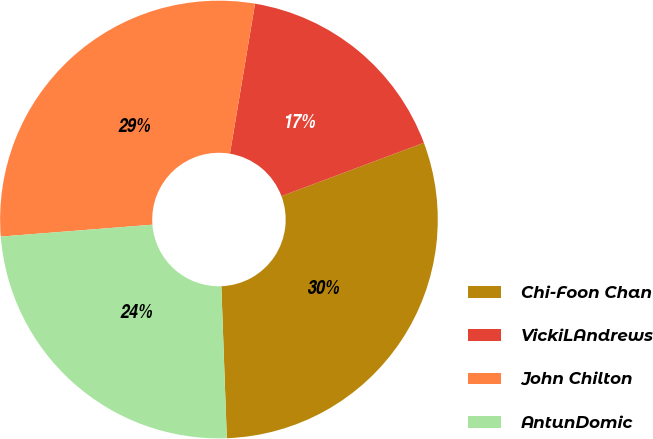<chart> <loc_0><loc_0><loc_500><loc_500><pie_chart><fcel>Chi-Foon Chan<fcel>VickiLAndrews<fcel>John Chilton<fcel>AntunDomic<nl><fcel>30.13%<fcel>16.66%<fcel>28.88%<fcel>24.33%<nl></chart> 